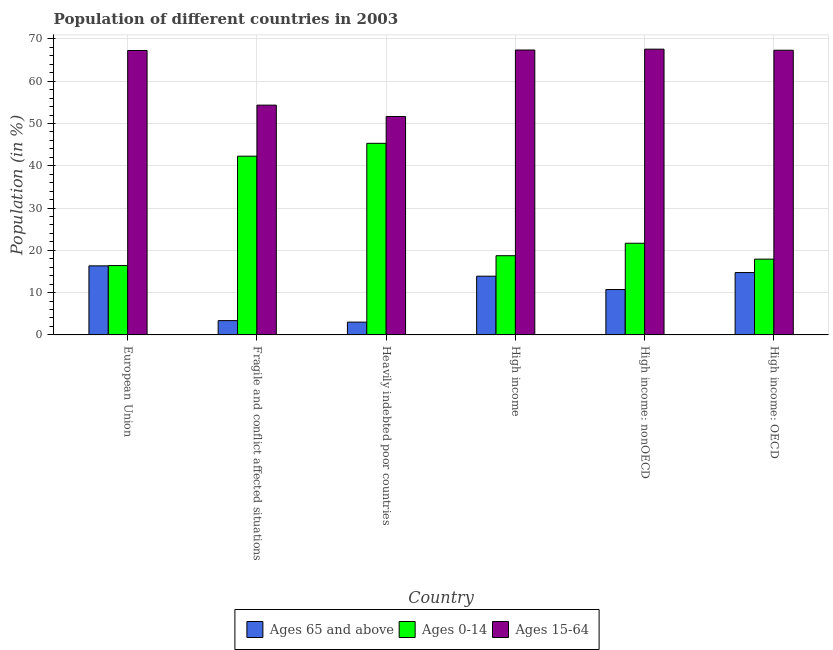How many different coloured bars are there?
Your response must be concise. 3. Are the number of bars per tick equal to the number of legend labels?
Offer a terse response. Yes. Are the number of bars on each tick of the X-axis equal?
Your answer should be very brief. Yes. What is the label of the 1st group of bars from the left?
Provide a short and direct response. European Union. In how many cases, is the number of bars for a given country not equal to the number of legend labels?
Give a very brief answer. 0. What is the percentage of population within the age-group 15-64 in High income?
Provide a succinct answer. 67.38. Across all countries, what is the maximum percentage of population within the age-group 0-14?
Make the answer very short. 45.32. Across all countries, what is the minimum percentage of population within the age-group of 65 and above?
Your answer should be very brief. 3.02. In which country was the percentage of population within the age-group 0-14 maximum?
Offer a very short reply. Heavily indebted poor countries. In which country was the percentage of population within the age-group 15-64 minimum?
Keep it short and to the point. Heavily indebted poor countries. What is the total percentage of population within the age-group of 65 and above in the graph?
Provide a short and direct response. 62.1. What is the difference between the percentage of population within the age-group of 65 and above in High income: OECD and that in High income: nonOECD?
Give a very brief answer. 4.02. What is the difference between the percentage of population within the age-group 15-64 in High income: nonOECD and the percentage of population within the age-group 0-14 in Heavily indebted poor countries?
Your answer should be very brief. 22.27. What is the average percentage of population within the age-group 15-64 per country?
Your answer should be very brief. 62.6. What is the difference between the percentage of population within the age-group of 65 and above and percentage of population within the age-group 15-64 in High income: OECD?
Offer a terse response. -52.58. What is the ratio of the percentage of population within the age-group of 65 and above in European Union to that in Fragile and conflict affected situations?
Ensure brevity in your answer.  4.83. Is the percentage of population within the age-group 15-64 in Fragile and conflict affected situations less than that in High income: nonOECD?
Keep it short and to the point. Yes. What is the difference between the highest and the second highest percentage of population within the age-group 0-14?
Your response must be concise. 3.04. What is the difference between the highest and the lowest percentage of population within the age-group 15-64?
Provide a succinct answer. 15.92. In how many countries, is the percentage of population within the age-group of 65 and above greater than the average percentage of population within the age-group of 65 and above taken over all countries?
Keep it short and to the point. 4. What does the 3rd bar from the left in High income represents?
Your answer should be very brief. Ages 15-64. What does the 2nd bar from the right in High income: OECD represents?
Provide a short and direct response. Ages 0-14. Is it the case that in every country, the sum of the percentage of population within the age-group of 65 and above and percentage of population within the age-group 0-14 is greater than the percentage of population within the age-group 15-64?
Offer a very short reply. No. Are the values on the major ticks of Y-axis written in scientific E-notation?
Provide a short and direct response. No. Does the graph contain any zero values?
Offer a very short reply. No. Does the graph contain grids?
Your response must be concise. Yes. How are the legend labels stacked?
Provide a short and direct response. Horizontal. What is the title of the graph?
Your answer should be very brief. Population of different countries in 2003. Does "Ages 20-50" appear as one of the legend labels in the graph?
Keep it short and to the point. No. What is the Population (in %) in Ages 65 and above in European Union?
Give a very brief answer. 16.33. What is the Population (in %) in Ages 0-14 in European Union?
Keep it short and to the point. 16.4. What is the Population (in %) in Ages 15-64 in European Union?
Keep it short and to the point. 67.27. What is the Population (in %) in Ages 65 and above in Fragile and conflict affected situations?
Your response must be concise. 3.38. What is the Population (in %) in Ages 0-14 in Fragile and conflict affected situations?
Provide a succinct answer. 42.27. What is the Population (in %) of Ages 15-64 in Fragile and conflict affected situations?
Give a very brief answer. 54.35. What is the Population (in %) in Ages 65 and above in Heavily indebted poor countries?
Offer a terse response. 3.02. What is the Population (in %) in Ages 0-14 in Heavily indebted poor countries?
Provide a succinct answer. 45.32. What is the Population (in %) of Ages 15-64 in Heavily indebted poor countries?
Ensure brevity in your answer.  51.66. What is the Population (in %) in Ages 65 and above in High income?
Your response must be concise. 13.89. What is the Population (in %) in Ages 0-14 in High income?
Your response must be concise. 18.73. What is the Population (in %) of Ages 15-64 in High income?
Offer a terse response. 67.38. What is the Population (in %) of Ages 65 and above in High income: nonOECD?
Your answer should be compact. 10.73. What is the Population (in %) of Ages 0-14 in High income: nonOECD?
Ensure brevity in your answer.  21.68. What is the Population (in %) in Ages 15-64 in High income: nonOECD?
Offer a very short reply. 67.58. What is the Population (in %) of Ages 65 and above in High income: OECD?
Make the answer very short. 14.75. What is the Population (in %) in Ages 0-14 in High income: OECD?
Your response must be concise. 17.92. What is the Population (in %) in Ages 15-64 in High income: OECD?
Offer a terse response. 67.33. Across all countries, what is the maximum Population (in %) in Ages 65 and above?
Your response must be concise. 16.33. Across all countries, what is the maximum Population (in %) of Ages 0-14?
Offer a very short reply. 45.32. Across all countries, what is the maximum Population (in %) in Ages 15-64?
Offer a terse response. 67.58. Across all countries, what is the minimum Population (in %) in Ages 65 and above?
Your answer should be very brief. 3.02. Across all countries, what is the minimum Population (in %) of Ages 0-14?
Ensure brevity in your answer.  16.4. Across all countries, what is the minimum Population (in %) of Ages 15-64?
Ensure brevity in your answer.  51.66. What is the total Population (in %) of Ages 65 and above in the graph?
Your answer should be very brief. 62.1. What is the total Population (in %) in Ages 0-14 in the graph?
Your answer should be compact. 162.32. What is the total Population (in %) in Ages 15-64 in the graph?
Your answer should be very brief. 375.57. What is the difference between the Population (in %) of Ages 65 and above in European Union and that in Fragile and conflict affected situations?
Your answer should be compact. 12.95. What is the difference between the Population (in %) in Ages 0-14 in European Union and that in Fragile and conflict affected situations?
Give a very brief answer. -25.87. What is the difference between the Population (in %) of Ages 15-64 in European Union and that in Fragile and conflict affected situations?
Make the answer very short. 12.92. What is the difference between the Population (in %) in Ages 65 and above in European Union and that in Heavily indebted poor countries?
Offer a very short reply. 13.3. What is the difference between the Population (in %) in Ages 0-14 in European Union and that in Heavily indebted poor countries?
Make the answer very short. -28.91. What is the difference between the Population (in %) in Ages 15-64 in European Union and that in Heavily indebted poor countries?
Your answer should be compact. 15.61. What is the difference between the Population (in %) in Ages 65 and above in European Union and that in High income?
Offer a very short reply. 2.44. What is the difference between the Population (in %) in Ages 0-14 in European Union and that in High income?
Your answer should be very brief. -2.33. What is the difference between the Population (in %) of Ages 15-64 in European Union and that in High income?
Keep it short and to the point. -0.11. What is the difference between the Population (in %) of Ages 65 and above in European Union and that in High income: nonOECD?
Give a very brief answer. 5.6. What is the difference between the Population (in %) in Ages 0-14 in European Union and that in High income: nonOECD?
Offer a very short reply. -5.28. What is the difference between the Population (in %) of Ages 15-64 in European Union and that in High income: nonOECD?
Your answer should be compact. -0.31. What is the difference between the Population (in %) in Ages 65 and above in European Union and that in High income: OECD?
Keep it short and to the point. 1.58. What is the difference between the Population (in %) in Ages 0-14 in European Union and that in High income: OECD?
Ensure brevity in your answer.  -1.52. What is the difference between the Population (in %) of Ages 15-64 in European Union and that in High income: OECD?
Your response must be concise. -0.06. What is the difference between the Population (in %) of Ages 65 and above in Fragile and conflict affected situations and that in Heavily indebted poor countries?
Ensure brevity in your answer.  0.36. What is the difference between the Population (in %) of Ages 0-14 in Fragile and conflict affected situations and that in Heavily indebted poor countries?
Provide a short and direct response. -3.04. What is the difference between the Population (in %) of Ages 15-64 in Fragile and conflict affected situations and that in Heavily indebted poor countries?
Your answer should be very brief. 2.69. What is the difference between the Population (in %) in Ages 65 and above in Fragile and conflict affected situations and that in High income?
Offer a terse response. -10.51. What is the difference between the Population (in %) in Ages 0-14 in Fragile and conflict affected situations and that in High income?
Offer a terse response. 23.54. What is the difference between the Population (in %) of Ages 15-64 in Fragile and conflict affected situations and that in High income?
Offer a terse response. -13.03. What is the difference between the Population (in %) in Ages 65 and above in Fragile and conflict affected situations and that in High income: nonOECD?
Offer a very short reply. -7.35. What is the difference between the Population (in %) in Ages 0-14 in Fragile and conflict affected situations and that in High income: nonOECD?
Ensure brevity in your answer.  20.59. What is the difference between the Population (in %) of Ages 15-64 in Fragile and conflict affected situations and that in High income: nonOECD?
Provide a succinct answer. -13.24. What is the difference between the Population (in %) in Ages 65 and above in Fragile and conflict affected situations and that in High income: OECD?
Give a very brief answer. -11.37. What is the difference between the Population (in %) in Ages 0-14 in Fragile and conflict affected situations and that in High income: OECD?
Make the answer very short. 24.35. What is the difference between the Population (in %) in Ages 15-64 in Fragile and conflict affected situations and that in High income: OECD?
Provide a short and direct response. -12.98. What is the difference between the Population (in %) in Ages 65 and above in Heavily indebted poor countries and that in High income?
Your answer should be very brief. -10.86. What is the difference between the Population (in %) of Ages 0-14 in Heavily indebted poor countries and that in High income?
Make the answer very short. 26.58. What is the difference between the Population (in %) of Ages 15-64 in Heavily indebted poor countries and that in High income?
Make the answer very short. -15.72. What is the difference between the Population (in %) of Ages 65 and above in Heavily indebted poor countries and that in High income: nonOECD?
Offer a terse response. -7.71. What is the difference between the Population (in %) of Ages 0-14 in Heavily indebted poor countries and that in High income: nonOECD?
Give a very brief answer. 23.63. What is the difference between the Population (in %) in Ages 15-64 in Heavily indebted poor countries and that in High income: nonOECD?
Provide a succinct answer. -15.92. What is the difference between the Population (in %) of Ages 65 and above in Heavily indebted poor countries and that in High income: OECD?
Your response must be concise. -11.72. What is the difference between the Population (in %) in Ages 0-14 in Heavily indebted poor countries and that in High income: OECD?
Your answer should be compact. 27.39. What is the difference between the Population (in %) in Ages 15-64 in Heavily indebted poor countries and that in High income: OECD?
Your response must be concise. -15.67. What is the difference between the Population (in %) in Ages 65 and above in High income and that in High income: nonOECD?
Your answer should be very brief. 3.15. What is the difference between the Population (in %) in Ages 0-14 in High income and that in High income: nonOECD?
Your answer should be compact. -2.95. What is the difference between the Population (in %) of Ages 15-64 in High income and that in High income: nonOECD?
Keep it short and to the point. -0.2. What is the difference between the Population (in %) of Ages 65 and above in High income and that in High income: OECD?
Offer a very short reply. -0.86. What is the difference between the Population (in %) of Ages 0-14 in High income and that in High income: OECD?
Your answer should be compact. 0.81. What is the difference between the Population (in %) in Ages 15-64 in High income and that in High income: OECD?
Your answer should be very brief. 0.06. What is the difference between the Population (in %) in Ages 65 and above in High income: nonOECD and that in High income: OECD?
Offer a very short reply. -4.02. What is the difference between the Population (in %) in Ages 0-14 in High income: nonOECD and that in High income: OECD?
Make the answer very short. 3.76. What is the difference between the Population (in %) in Ages 15-64 in High income: nonOECD and that in High income: OECD?
Offer a terse response. 0.26. What is the difference between the Population (in %) of Ages 65 and above in European Union and the Population (in %) of Ages 0-14 in Fragile and conflict affected situations?
Your answer should be very brief. -25.94. What is the difference between the Population (in %) in Ages 65 and above in European Union and the Population (in %) in Ages 15-64 in Fragile and conflict affected situations?
Provide a succinct answer. -38.02. What is the difference between the Population (in %) of Ages 0-14 in European Union and the Population (in %) of Ages 15-64 in Fragile and conflict affected situations?
Give a very brief answer. -37.95. What is the difference between the Population (in %) of Ages 65 and above in European Union and the Population (in %) of Ages 0-14 in Heavily indebted poor countries?
Make the answer very short. -28.99. What is the difference between the Population (in %) of Ages 65 and above in European Union and the Population (in %) of Ages 15-64 in Heavily indebted poor countries?
Offer a terse response. -35.33. What is the difference between the Population (in %) in Ages 0-14 in European Union and the Population (in %) in Ages 15-64 in Heavily indebted poor countries?
Make the answer very short. -35.26. What is the difference between the Population (in %) of Ages 65 and above in European Union and the Population (in %) of Ages 0-14 in High income?
Your answer should be compact. -2.4. What is the difference between the Population (in %) of Ages 65 and above in European Union and the Population (in %) of Ages 15-64 in High income?
Give a very brief answer. -51.05. What is the difference between the Population (in %) of Ages 0-14 in European Union and the Population (in %) of Ages 15-64 in High income?
Make the answer very short. -50.98. What is the difference between the Population (in %) in Ages 65 and above in European Union and the Population (in %) in Ages 0-14 in High income: nonOECD?
Give a very brief answer. -5.35. What is the difference between the Population (in %) of Ages 65 and above in European Union and the Population (in %) of Ages 15-64 in High income: nonOECD?
Offer a terse response. -51.26. What is the difference between the Population (in %) of Ages 0-14 in European Union and the Population (in %) of Ages 15-64 in High income: nonOECD?
Your answer should be very brief. -51.18. What is the difference between the Population (in %) of Ages 65 and above in European Union and the Population (in %) of Ages 0-14 in High income: OECD?
Provide a short and direct response. -1.59. What is the difference between the Population (in %) in Ages 65 and above in European Union and the Population (in %) in Ages 15-64 in High income: OECD?
Give a very brief answer. -51. What is the difference between the Population (in %) in Ages 0-14 in European Union and the Population (in %) in Ages 15-64 in High income: OECD?
Ensure brevity in your answer.  -50.93. What is the difference between the Population (in %) in Ages 65 and above in Fragile and conflict affected situations and the Population (in %) in Ages 0-14 in Heavily indebted poor countries?
Offer a very short reply. -41.93. What is the difference between the Population (in %) in Ages 65 and above in Fragile and conflict affected situations and the Population (in %) in Ages 15-64 in Heavily indebted poor countries?
Offer a very short reply. -48.28. What is the difference between the Population (in %) in Ages 0-14 in Fragile and conflict affected situations and the Population (in %) in Ages 15-64 in Heavily indebted poor countries?
Offer a terse response. -9.39. What is the difference between the Population (in %) of Ages 65 and above in Fragile and conflict affected situations and the Population (in %) of Ages 0-14 in High income?
Give a very brief answer. -15.35. What is the difference between the Population (in %) in Ages 65 and above in Fragile and conflict affected situations and the Population (in %) in Ages 15-64 in High income?
Give a very brief answer. -64. What is the difference between the Population (in %) in Ages 0-14 in Fragile and conflict affected situations and the Population (in %) in Ages 15-64 in High income?
Ensure brevity in your answer.  -25.11. What is the difference between the Population (in %) in Ages 65 and above in Fragile and conflict affected situations and the Population (in %) in Ages 0-14 in High income: nonOECD?
Keep it short and to the point. -18.3. What is the difference between the Population (in %) of Ages 65 and above in Fragile and conflict affected situations and the Population (in %) of Ages 15-64 in High income: nonOECD?
Offer a terse response. -64.2. What is the difference between the Population (in %) of Ages 0-14 in Fragile and conflict affected situations and the Population (in %) of Ages 15-64 in High income: nonOECD?
Provide a short and direct response. -25.31. What is the difference between the Population (in %) in Ages 65 and above in Fragile and conflict affected situations and the Population (in %) in Ages 0-14 in High income: OECD?
Your response must be concise. -14.54. What is the difference between the Population (in %) of Ages 65 and above in Fragile and conflict affected situations and the Population (in %) of Ages 15-64 in High income: OECD?
Keep it short and to the point. -63.95. What is the difference between the Population (in %) in Ages 0-14 in Fragile and conflict affected situations and the Population (in %) in Ages 15-64 in High income: OECD?
Your response must be concise. -25.06. What is the difference between the Population (in %) in Ages 65 and above in Heavily indebted poor countries and the Population (in %) in Ages 0-14 in High income?
Provide a short and direct response. -15.71. What is the difference between the Population (in %) in Ages 65 and above in Heavily indebted poor countries and the Population (in %) in Ages 15-64 in High income?
Keep it short and to the point. -64.36. What is the difference between the Population (in %) in Ages 0-14 in Heavily indebted poor countries and the Population (in %) in Ages 15-64 in High income?
Your answer should be very brief. -22.07. What is the difference between the Population (in %) of Ages 65 and above in Heavily indebted poor countries and the Population (in %) of Ages 0-14 in High income: nonOECD?
Your response must be concise. -18.66. What is the difference between the Population (in %) in Ages 65 and above in Heavily indebted poor countries and the Population (in %) in Ages 15-64 in High income: nonOECD?
Offer a terse response. -64.56. What is the difference between the Population (in %) in Ages 0-14 in Heavily indebted poor countries and the Population (in %) in Ages 15-64 in High income: nonOECD?
Ensure brevity in your answer.  -22.27. What is the difference between the Population (in %) of Ages 65 and above in Heavily indebted poor countries and the Population (in %) of Ages 0-14 in High income: OECD?
Provide a succinct answer. -14.9. What is the difference between the Population (in %) of Ages 65 and above in Heavily indebted poor countries and the Population (in %) of Ages 15-64 in High income: OECD?
Offer a terse response. -64.3. What is the difference between the Population (in %) of Ages 0-14 in Heavily indebted poor countries and the Population (in %) of Ages 15-64 in High income: OECD?
Give a very brief answer. -22.01. What is the difference between the Population (in %) in Ages 65 and above in High income and the Population (in %) in Ages 0-14 in High income: nonOECD?
Offer a terse response. -7.8. What is the difference between the Population (in %) in Ages 65 and above in High income and the Population (in %) in Ages 15-64 in High income: nonOECD?
Ensure brevity in your answer.  -53.7. What is the difference between the Population (in %) of Ages 0-14 in High income and the Population (in %) of Ages 15-64 in High income: nonOECD?
Provide a short and direct response. -48.85. What is the difference between the Population (in %) in Ages 65 and above in High income and the Population (in %) in Ages 0-14 in High income: OECD?
Your response must be concise. -4.04. What is the difference between the Population (in %) in Ages 65 and above in High income and the Population (in %) in Ages 15-64 in High income: OECD?
Keep it short and to the point. -53.44. What is the difference between the Population (in %) of Ages 0-14 in High income and the Population (in %) of Ages 15-64 in High income: OECD?
Offer a terse response. -48.6. What is the difference between the Population (in %) of Ages 65 and above in High income: nonOECD and the Population (in %) of Ages 0-14 in High income: OECD?
Your response must be concise. -7.19. What is the difference between the Population (in %) in Ages 65 and above in High income: nonOECD and the Population (in %) in Ages 15-64 in High income: OECD?
Offer a very short reply. -56.59. What is the difference between the Population (in %) in Ages 0-14 in High income: nonOECD and the Population (in %) in Ages 15-64 in High income: OECD?
Your answer should be very brief. -45.65. What is the average Population (in %) of Ages 65 and above per country?
Your response must be concise. 10.35. What is the average Population (in %) in Ages 0-14 per country?
Your response must be concise. 27.05. What is the average Population (in %) of Ages 15-64 per country?
Your response must be concise. 62.6. What is the difference between the Population (in %) in Ages 65 and above and Population (in %) in Ages 0-14 in European Union?
Make the answer very short. -0.07. What is the difference between the Population (in %) of Ages 65 and above and Population (in %) of Ages 15-64 in European Union?
Make the answer very short. -50.94. What is the difference between the Population (in %) in Ages 0-14 and Population (in %) in Ages 15-64 in European Union?
Your response must be concise. -50.87. What is the difference between the Population (in %) of Ages 65 and above and Population (in %) of Ages 0-14 in Fragile and conflict affected situations?
Provide a succinct answer. -38.89. What is the difference between the Population (in %) in Ages 65 and above and Population (in %) in Ages 15-64 in Fragile and conflict affected situations?
Your answer should be very brief. -50.97. What is the difference between the Population (in %) in Ages 0-14 and Population (in %) in Ages 15-64 in Fragile and conflict affected situations?
Make the answer very short. -12.08. What is the difference between the Population (in %) in Ages 65 and above and Population (in %) in Ages 0-14 in Heavily indebted poor countries?
Your answer should be compact. -42.29. What is the difference between the Population (in %) of Ages 65 and above and Population (in %) of Ages 15-64 in Heavily indebted poor countries?
Ensure brevity in your answer.  -48.64. What is the difference between the Population (in %) of Ages 0-14 and Population (in %) of Ages 15-64 in Heavily indebted poor countries?
Make the answer very short. -6.35. What is the difference between the Population (in %) in Ages 65 and above and Population (in %) in Ages 0-14 in High income?
Ensure brevity in your answer.  -4.84. What is the difference between the Population (in %) of Ages 65 and above and Population (in %) of Ages 15-64 in High income?
Your answer should be very brief. -53.5. What is the difference between the Population (in %) of Ages 0-14 and Population (in %) of Ages 15-64 in High income?
Keep it short and to the point. -48.65. What is the difference between the Population (in %) in Ages 65 and above and Population (in %) in Ages 0-14 in High income: nonOECD?
Ensure brevity in your answer.  -10.95. What is the difference between the Population (in %) of Ages 65 and above and Population (in %) of Ages 15-64 in High income: nonOECD?
Offer a terse response. -56.85. What is the difference between the Population (in %) in Ages 0-14 and Population (in %) in Ages 15-64 in High income: nonOECD?
Give a very brief answer. -45.9. What is the difference between the Population (in %) in Ages 65 and above and Population (in %) in Ages 0-14 in High income: OECD?
Keep it short and to the point. -3.17. What is the difference between the Population (in %) in Ages 65 and above and Population (in %) in Ages 15-64 in High income: OECD?
Ensure brevity in your answer.  -52.58. What is the difference between the Population (in %) of Ages 0-14 and Population (in %) of Ages 15-64 in High income: OECD?
Your answer should be compact. -49.4. What is the ratio of the Population (in %) in Ages 65 and above in European Union to that in Fragile and conflict affected situations?
Your answer should be compact. 4.83. What is the ratio of the Population (in %) of Ages 0-14 in European Union to that in Fragile and conflict affected situations?
Make the answer very short. 0.39. What is the ratio of the Population (in %) of Ages 15-64 in European Union to that in Fragile and conflict affected situations?
Provide a short and direct response. 1.24. What is the ratio of the Population (in %) of Ages 65 and above in European Union to that in Heavily indebted poor countries?
Provide a succinct answer. 5.4. What is the ratio of the Population (in %) in Ages 0-14 in European Union to that in Heavily indebted poor countries?
Give a very brief answer. 0.36. What is the ratio of the Population (in %) in Ages 15-64 in European Union to that in Heavily indebted poor countries?
Your response must be concise. 1.3. What is the ratio of the Population (in %) in Ages 65 and above in European Union to that in High income?
Make the answer very short. 1.18. What is the ratio of the Population (in %) of Ages 0-14 in European Union to that in High income?
Provide a short and direct response. 0.88. What is the ratio of the Population (in %) of Ages 15-64 in European Union to that in High income?
Provide a short and direct response. 1. What is the ratio of the Population (in %) of Ages 65 and above in European Union to that in High income: nonOECD?
Your answer should be very brief. 1.52. What is the ratio of the Population (in %) in Ages 0-14 in European Union to that in High income: nonOECD?
Keep it short and to the point. 0.76. What is the ratio of the Population (in %) of Ages 15-64 in European Union to that in High income: nonOECD?
Your answer should be very brief. 1. What is the ratio of the Population (in %) of Ages 65 and above in European Union to that in High income: OECD?
Provide a short and direct response. 1.11. What is the ratio of the Population (in %) in Ages 0-14 in European Union to that in High income: OECD?
Ensure brevity in your answer.  0.92. What is the ratio of the Population (in %) of Ages 15-64 in European Union to that in High income: OECD?
Your answer should be very brief. 1. What is the ratio of the Population (in %) in Ages 65 and above in Fragile and conflict affected situations to that in Heavily indebted poor countries?
Your response must be concise. 1.12. What is the ratio of the Population (in %) of Ages 0-14 in Fragile and conflict affected situations to that in Heavily indebted poor countries?
Provide a short and direct response. 0.93. What is the ratio of the Population (in %) of Ages 15-64 in Fragile and conflict affected situations to that in Heavily indebted poor countries?
Give a very brief answer. 1.05. What is the ratio of the Population (in %) of Ages 65 and above in Fragile and conflict affected situations to that in High income?
Keep it short and to the point. 0.24. What is the ratio of the Population (in %) in Ages 0-14 in Fragile and conflict affected situations to that in High income?
Offer a very short reply. 2.26. What is the ratio of the Population (in %) of Ages 15-64 in Fragile and conflict affected situations to that in High income?
Provide a succinct answer. 0.81. What is the ratio of the Population (in %) of Ages 65 and above in Fragile and conflict affected situations to that in High income: nonOECD?
Keep it short and to the point. 0.31. What is the ratio of the Population (in %) of Ages 0-14 in Fragile and conflict affected situations to that in High income: nonOECD?
Keep it short and to the point. 1.95. What is the ratio of the Population (in %) in Ages 15-64 in Fragile and conflict affected situations to that in High income: nonOECD?
Offer a terse response. 0.8. What is the ratio of the Population (in %) in Ages 65 and above in Fragile and conflict affected situations to that in High income: OECD?
Make the answer very short. 0.23. What is the ratio of the Population (in %) in Ages 0-14 in Fragile and conflict affected situations to that in High income: OECD?
Give a very brief answer. 2.36. What is the ratio of the Population (in %) in Ages 15-64 in Fragile and conflict affected situations to that in High income: OECD?
Offer a terse response. 0.81. What is the ratio of the Population (in %) in Ages 65 and above in Heavily indebted poor countries to that in High income?
Your answer should be very brief. 0.22. What is the ratio of the Population (in %) in Ages 0-14 in Heavily indebted poor countries to that in High income?
Provide a succinct answer. 2.42. What is the ratio of the Population (in %) of Ages 15-64 in Heavily indebted poor countries to that in High income?
Give a very brief answer. 0.77. What is the ratio of the Population (in %) in Ages 65 and above in Heavily indebted poor countries to that in High income: nonOECD?
Make the answer very short. 0.28. What is the ratio of the Population (in %) in Ages 0-14 in Heavily indebted poor countries to that in High income: nonOECD?
Provide a short and direct response. 2.09. What is the ratio of the Population (in %) in Ages 15-64 in Heavily indebted poor countries to that in High income: nonOECD?
Your answer should be very brief. 0.76. What is the ratio of the Population (in %) of Ages 65 and above in Heavily indebted poor countries to that in High income: OECD?
Your answer should be very brief. 0.21. What is the ratio of the Population (in %) in Ages 0-14 in Heavily indebted poor countries to that in High income: OECD?
Provide a succinct answer. 2.53. What is the ratio of the Population (in %) in Ages 15-64 in Heavily indebted poor countries to that in High income: OECD?
Offer a very short reply. 0.77. What is the ratio of the Population (in %) in Ages 65 and above in High income to that in High income: nonOECD?
Keep it short and to the point. 1.29. What is the ratio of the Population (in %) in Ages 0-14 in High income to that in High income: nonOECD?
Your answer should be very brief. 0.86. What is the ratio of the Population (in %) of Ages 15-64 in High income to that in High income: nonOECD?
Ensure brevity in your answer.  1. What is the ratio of the Population (in %) in Ages 65 and above in High income to that in High income: OECD?
Keep it short and to the point. 0.94. What is the ratio of the Population (in %) in Ages 0-14 in High income to that in High income: OECD?
Give a very brief answer. 1.05. What is the ratio of the Population (in %) of Ages 15-64 in High income to that in High income: OECD?
Your answer should be very brief. 1. What is the ratio of the Population (in %) in Ages 65 and above in High income: nonOECD to that in High income: OECD?
Your response must be concise. 0.73. What is the ratio of the Population (in %) in Ages 0-14 in High income: nonOECD to that in High income: OECD?
Make the answer very short. 1.21. What is the difference between the highest and the second highest Population (in %) in Ages 65 and above?
Ensure brevity in your answer.  1.58. What is the difference between the highest and the second highest Population (in %) in Ages 0-14?
Your response must be concise. 3.04. What is the difference between the highest and the second highest Population (in %) in Ages 15-64?
Make the answer very short. 0.2. What is the difference between the highest and the lowest Population (in %) in Ages 65 and above?
Your answer should be compact. 13.3. What is the difference between the highest and the lowest Population (in %) in Ages 0-14?
Offer a terse response. 28.91. What is the difference between the highest and the lowest Population (in %) in Ages 15-64?
Provide a succinct answer. 15.92. 